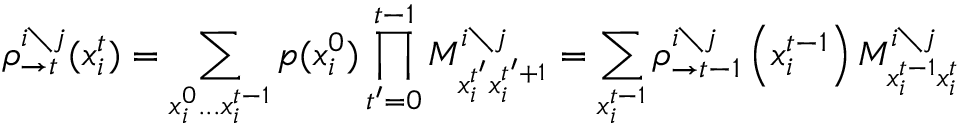<formula> <loc_0><loc_0><loc_500><loc_500>\rho _ { \rightarrow t } ^ { i \ j } ( x _ { i } ^ { t } ) = \sum _ { x _ { i } ^ { 0 } \dots x _ { i } ^ { t - 1 } } p ( x _ { i } ^ { 0 } ) \prod _ { t ^ { \prime } = 0 } ^ { t - 1 } M _ { x _ { i } ^ { t ^ { \prime } } x _ { i } ^ { t ^ { \prime } + 1 } } ^ { i \ j } = \sum _ { x _ { i } ^ { t - 1 } } \rho _ { \rightarrow t - 1 } ^ { i \ j } \left ( x _ { i } ^ { t - 1 } \right ) M _ { x _ { i } ^ { t - 1 } x _ { i } ^ { t } } ^ { i \ j }</formula> 